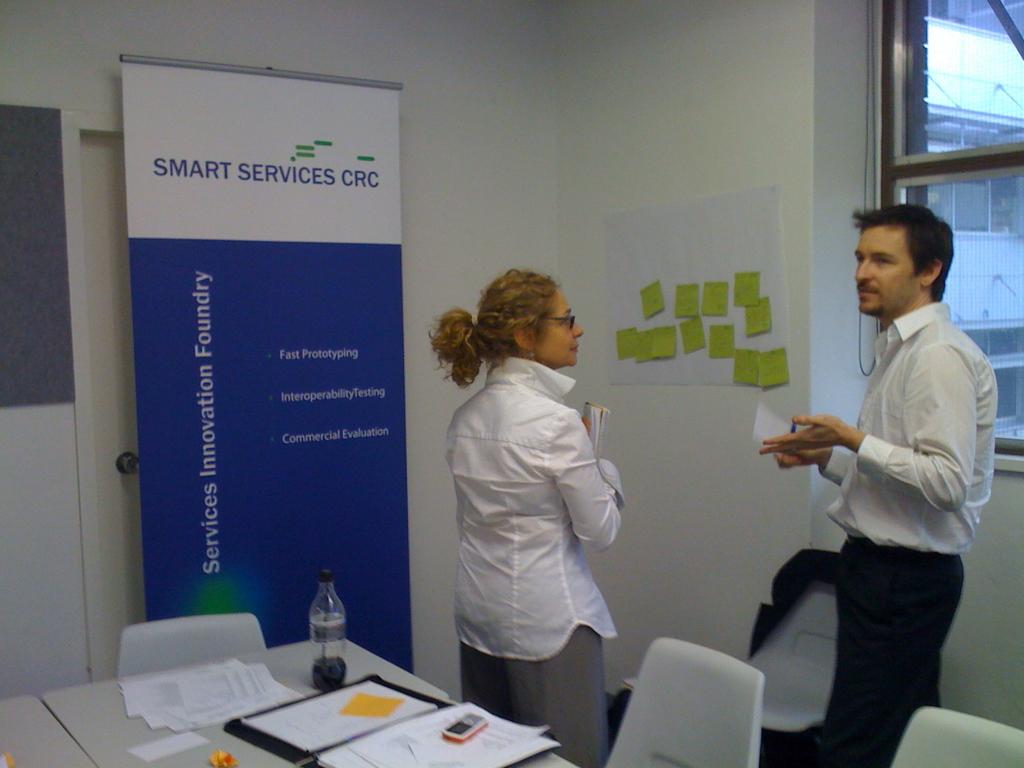What services company is shown?
Give a very brief answer. Smart services crc. What kind of foundry is it?
Your answer should be very brief. Services innovation. 